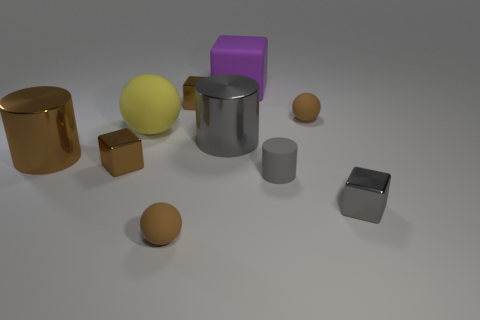Subtract all cubes. How many objects are left? 6 Subtract 0 purple spheres. How many objects are left? 10 Subtract all large yellow things. Subtract all small rubber balls. How many objects are left? 7 Add 3 yellow objects. How many yellow objects are left? 4 Add 8 small rubber cylinders. How many small rubber cylinders exist? 9 